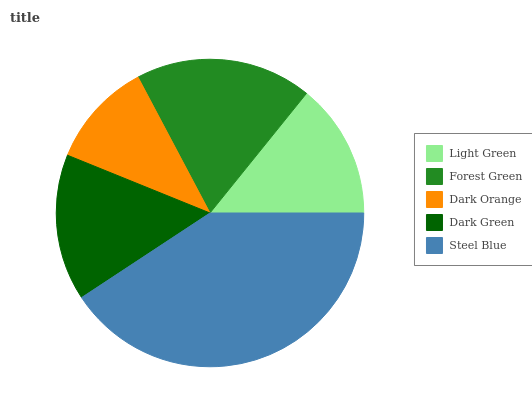Is Dark Orange the minimum?
Answer yes or no. Yes. Is Steel Blue the maximum?
Answer yes or no. Yes. Is Forest Green the minimum?
Answer yes or no. No. Is Forest Green the maximum?
Answer yes or no. No. Is Forest Green greater than Light Green?
Answer yes or no. Yes. Is Light Green less than Forest Green?
Answer yes or no. Yes. Is Light Green greater than Forest Green?
Answer yes or no. No. Is Forest Green less than Light Green?
Answer yes or no. No. Is Dark Green the high median?
Answer yes or no. Yes. Is Dark Green the low median?
Answer yes or no. Yes. Is Dark Orange the high median?
Answer yes or no. No. Is Light Green the low median?
Answer yes or no. No. 